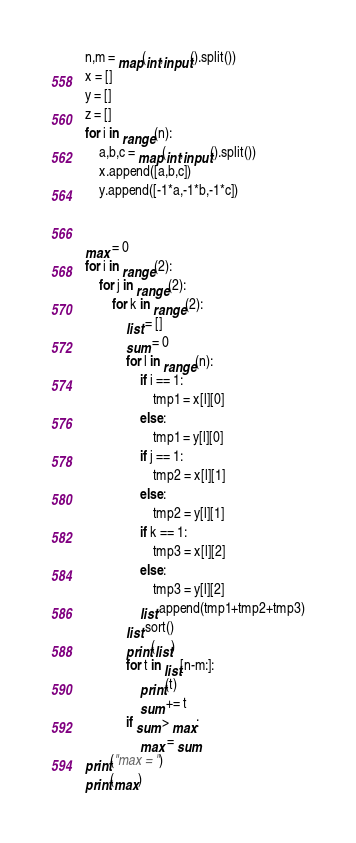Convert code to text. <code><loc_0><loc_0><loc_500><loc_500><_Python_>n,m = map(int,input().split())
x = []
y = []
z = []
for i in range(n):
    a,b,c = map(int,input().split())
    x.append([a,b,c])
    y.append([-1*a,-1*b,-1*c])


max = 0
for i in range(2):
    for j in range(2):
        for k in range(2):
            list = []
            sum = 0
            for l in range(n):
                if i == 1:
                    tmp1 = x[l][0]
                else:
                    tmp1 = y[l][0]
                if j == 1:
                    tmp2 = x[l][1]
                else:
                    tmp2 = y[l][1]
                if k == 1:
                    tmp3 = x[l][2]
                else:
                    tmp3 = y[l][2]
                list.append(tmp1+tmp2+tmp3)
            list.sort()
            print(list)
            for t in list[n-m:]:
                print(t)
                sum += t
            if sum > max:
                max = sum
print("max = ")
print(max)
</code> 